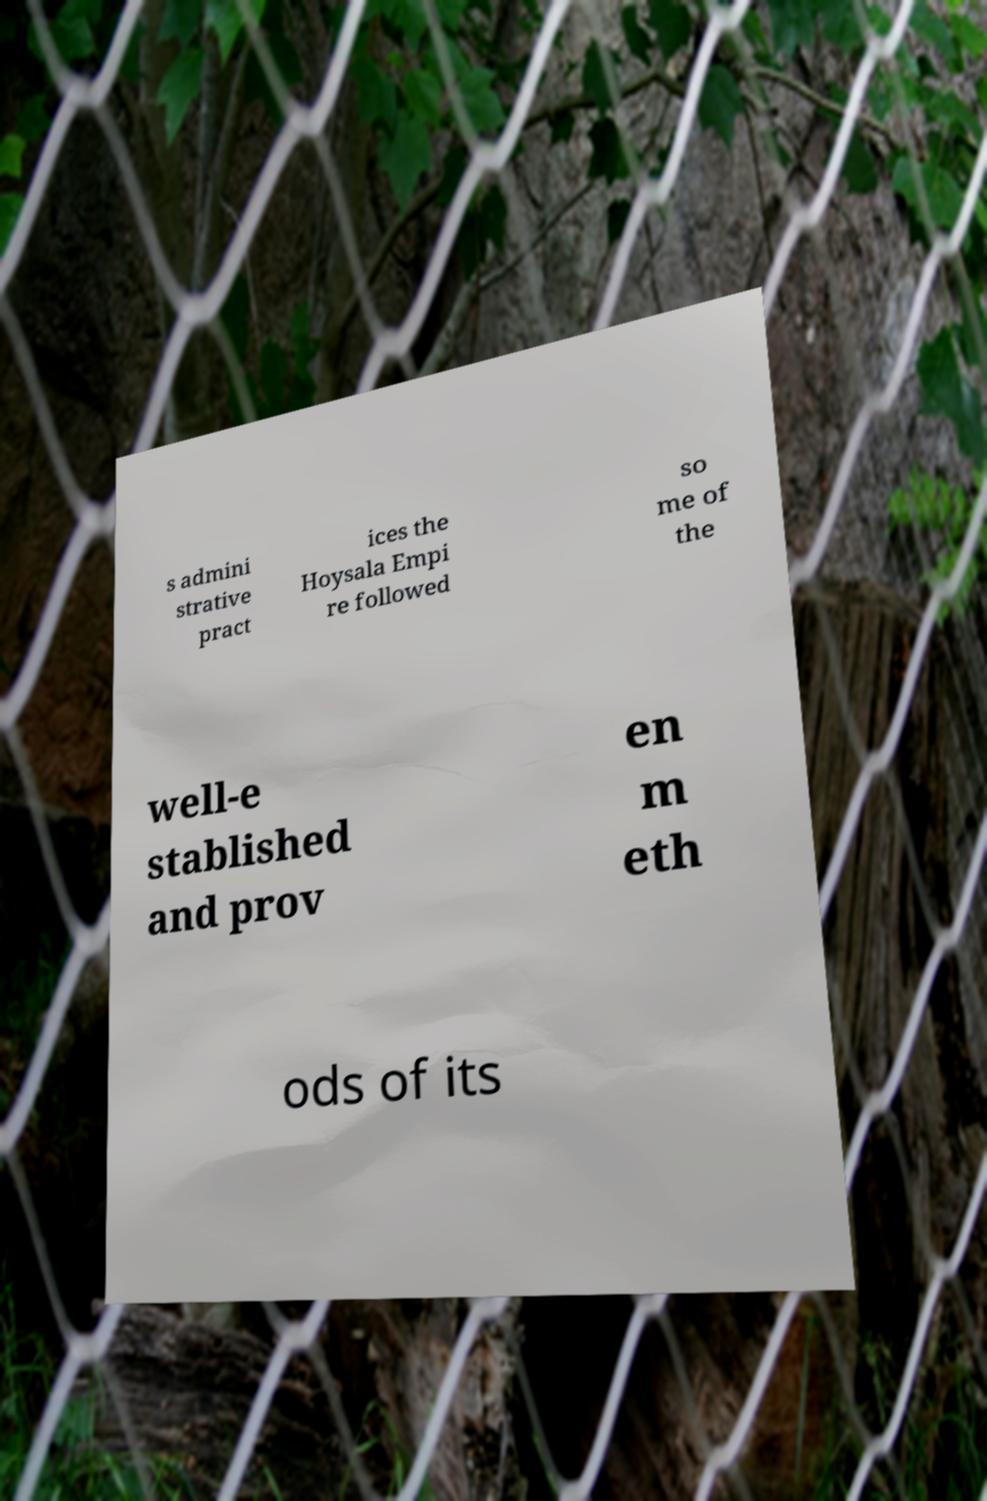Can you read and provide the text displayed in the image?This photo seems to have some interesting text. Can you extract and type it out for me? s admini strative pract ices the Hoysala Empi re followed so me of the well-e stablished and prov en m eth ods of its 